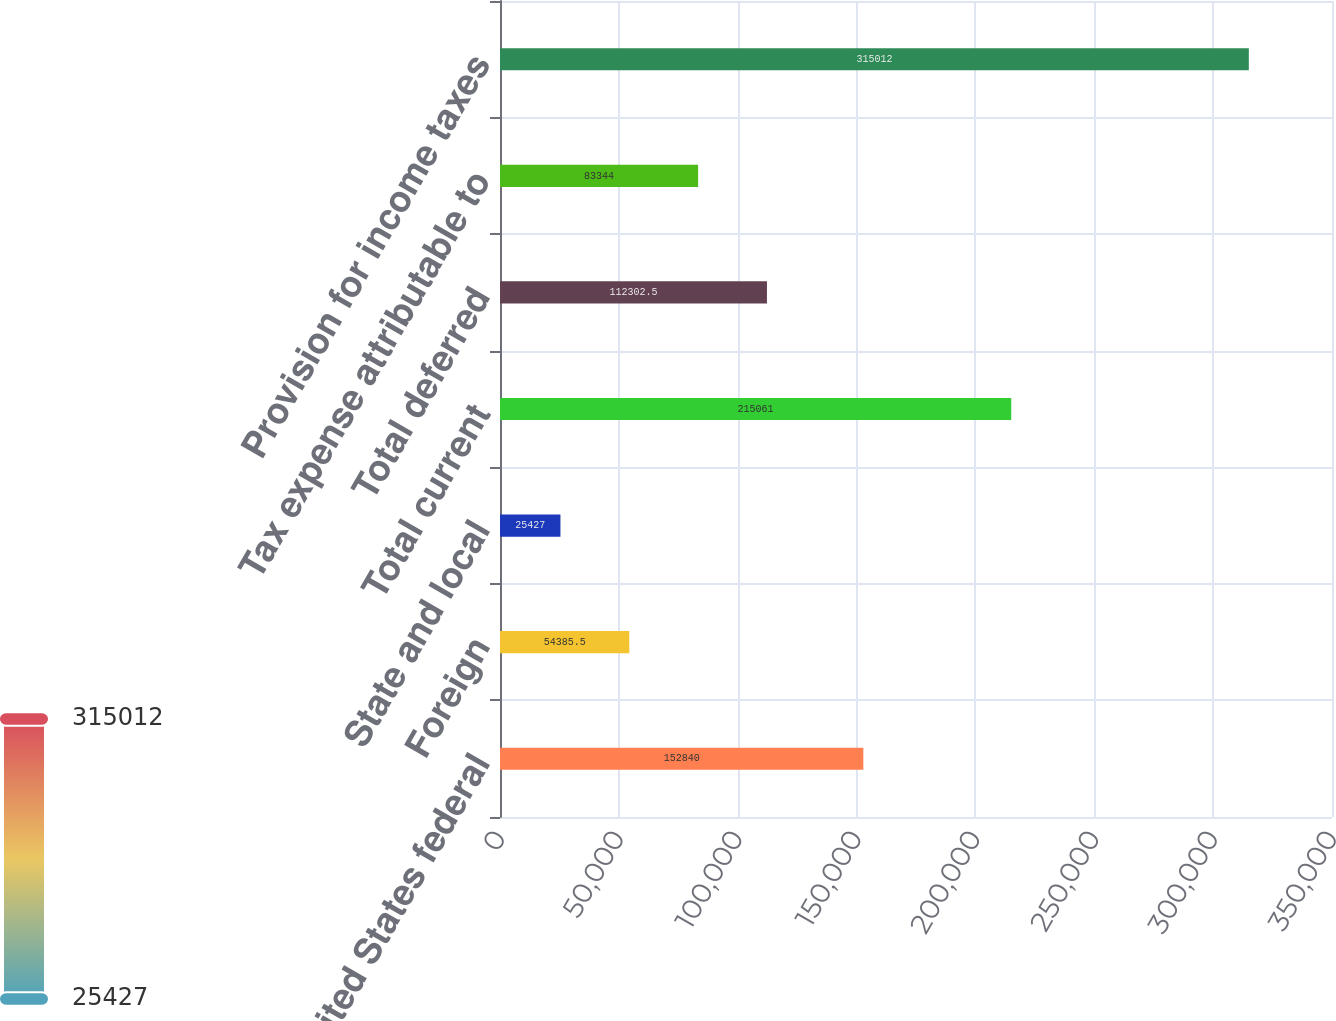<chart> <loc_0><loc_0><loc_500><loc_500><bar_chart><fcel>United States federal<fcel>Foreign<fcel>State and local<fcel>Total current<fcel>Total deferred<fcel>Tax expense attributable to<fcel>Provision for income taxes<nl><fcel>152840<fcel>54385.5<fcel>25427<fcel>215061<fcel>112302<fcel>83344<fcel>315012<nl></chart> 